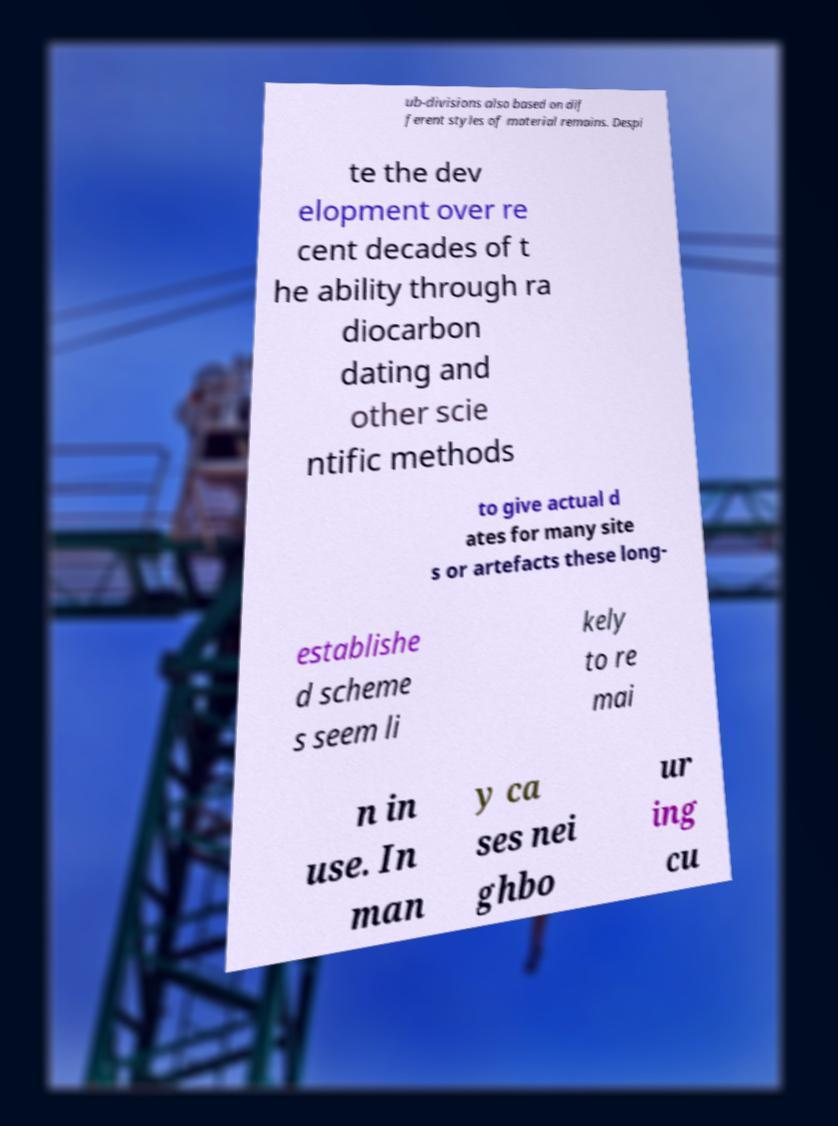Could you assist in decoding the text presented in this image and type it out clearly? ub-divisions also based on dif ferent styles of material remains. Despi te the dev elopment over re cent decades of t he ability through ra diocarbon dating and other scie ntific methods to give actual d ates for many site s or artefacts these long- establishe d scheme s seem li kely to re mai n in use. In man y ca ses nei ghbo ur ing cu 